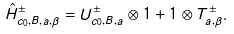<formula> <loc_0><loc_0><loc_500><loc_500>\hat { H } ^ { \pm } _ { c _ { 0 } , B , a , \beta } = U _ { c _ { 0 } , B , a } ^ { \pm } \otimes 1 + 1 \otimes T ^ { \pm } _ { a , \beta } .</formula> 